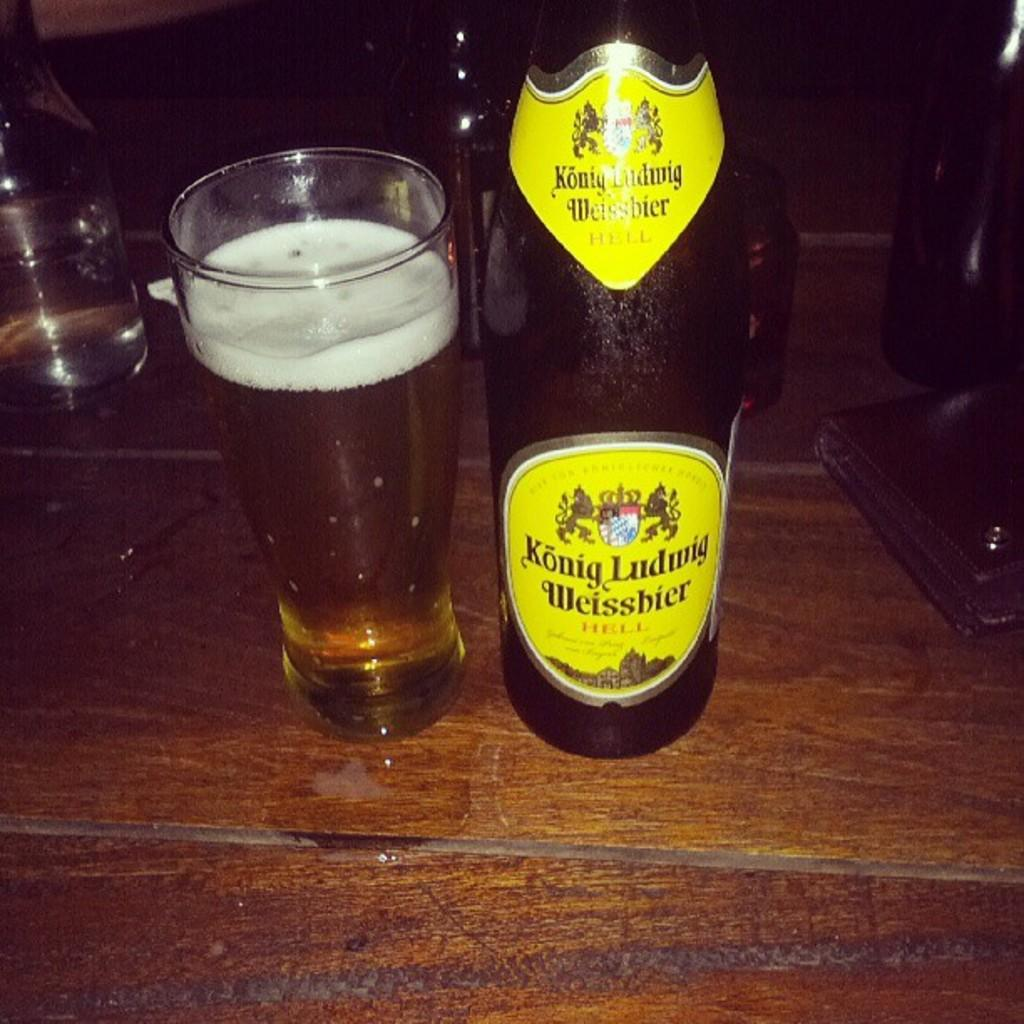Provide a one-sentence caption for the provided image. A large bottle of Konig Ludwig Weissbier is on a table with a full glass. 